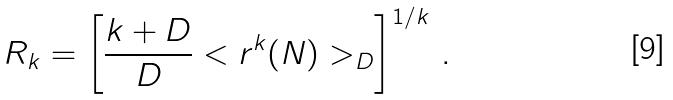<formula> <loc_0><loc_0><loc_500><loc_500>R _ { k } = \left [ \frac { k + D } { D } < r ^ { k } ( N ) > _ { D } \right ] ^ { 1 / k } \, .</formula> 